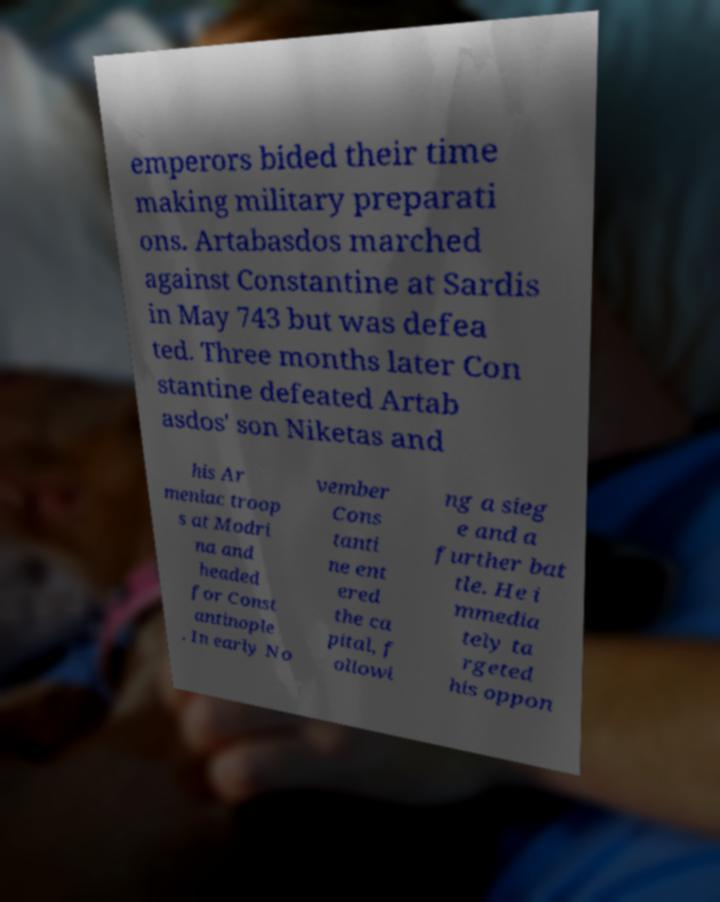Could you assist in decoding the text presented in this image and type it out clearly? emperors bided their time making military preparati ons. Artabasdos marched against Constantine at Sardis in May 743 but was defea ted. Three months later Con stantine defeated Artab asdos' son Niketas and his Ar meniac troop s at Modri na and headed for Const antinople . In early No vember Cons tanti ne ent ered the ca pital, f ollowi ng a sieg e and a further bat tle. He i mmedia tely ta rgeted his oppon 